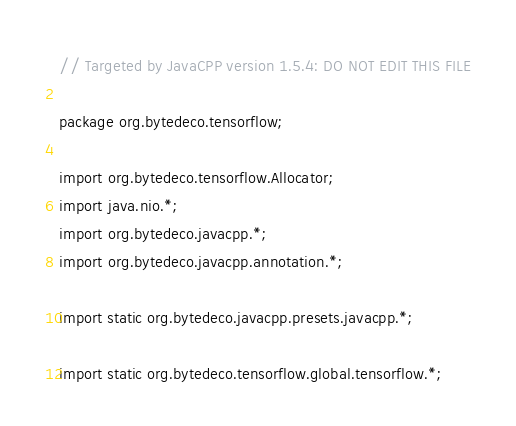Convert code to text. <code><loc_0><loc_0><loc_500><loc_500><_Java_>// Targeted by JavaCPP version 1.5.4: DO NOT EDIT THIS FILE

package org.bytedeco.tensorflow;

import org.bytedeco.tensorflow.Allocator;
import java.nio.*;
import org.bytedeco.javacpp.*;
import org.bytedeco.javacpp.annotation.*;

import static org.bytedeco.javacpp.presets.javacpp.*;

import static org.bytedeco.tensorflow.global.tensorflow.*;

</code> 